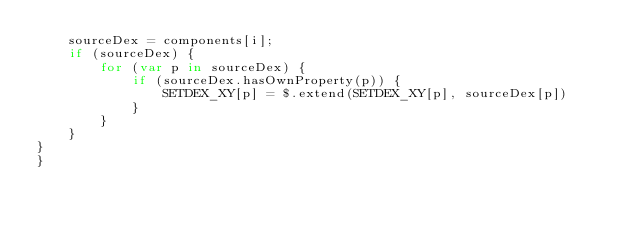Convert code to text. <code><loc_0><loc_0><loc_500><loc_500><_JavaScript_>    sourceDex = components[i];
    if (sourceDex) {
        for (var p in sourceDex) {
            if (sourceDex.hasOwnProperty(p)) {
                SETDEX_XY[p] = $.extend(SETDEX_XY[p], sourceDex[p])
            }
        }
    }
}
}</code> 